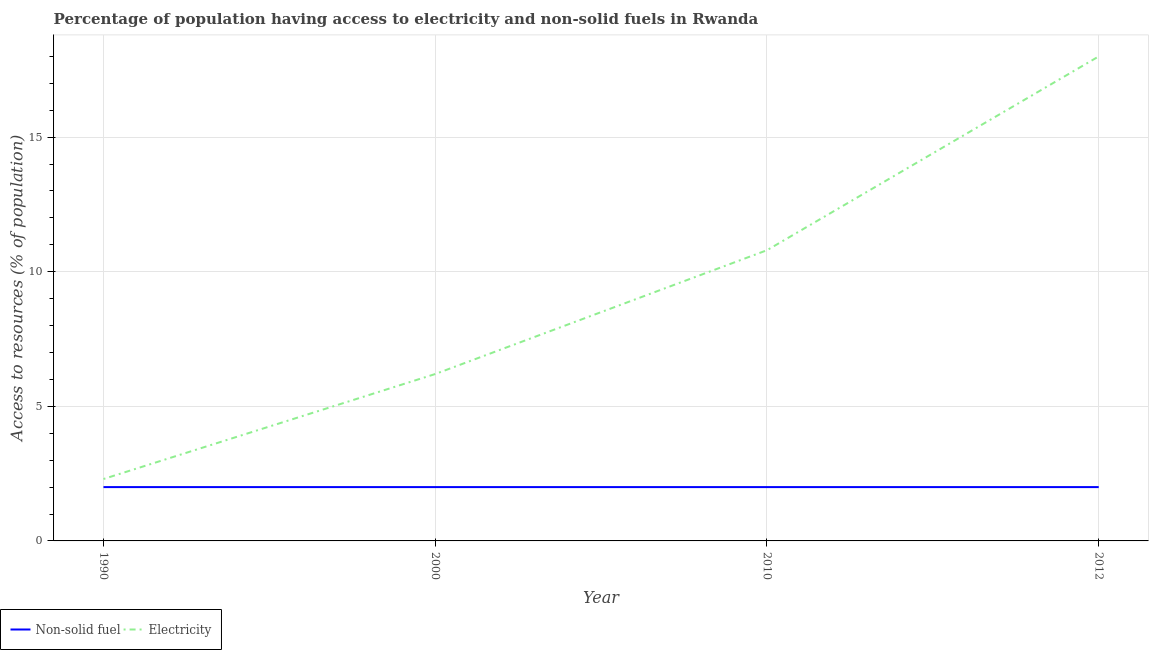Is the number of lines equal to the number of legend labels?
Give a very brief answer. Yes. In which year was the percentage of population having access to non-solid fuel maximum?
Your answer should be compact. 1990. What is the total percentage of population having access to electricity in the graph?
Keep it short and to the point. 37.3. What is the difference between the percentage of population having access to non-solid fuel in 1990 and that in 2010?
Ensure brevity in your answer.  0. What is the difference between the percentage of population having access to electricity in 2010 and the percentage of population having access to non-solid fuel in 2012?
Make the answer very short. 8.8. What is the average percentage of population having access to non-solid fuel per year?
Give a very brief answer. 2. In the year 2012, what is the difference between the percentage of population having access to electricity and percentage of population having access to non-solid fuel?
Offer a very short reply. 16. Is the percentage of population having access to non-solid fuel strictly greater than the percentage of population having access to electricity over the years?
Give a very brief answer. No. Is the percentage of population having access to non-solid fuel strictly less than the percentage of population having access to electricity over the years?
Give a very brief answer. Yes. What is the difference between two consecutive major ticks on the Y-axis?
Your answer should be very brief. 5. Are the values on the major ticks of Y-axis written in scientific E-notation?
Give a very brief answer. No. Does the graph contain any zero values?
Give a very brief answer. No. Does the graph contain grids?
Make the answer very short. Yes. How are the legend labels stacked?
Make the answer very short. Horizontal. What is the title of the graph?
Make the answer very short. Percentage of population having access to electricity and non-solid fuels in Rwanda. What is the label or title of the X-axis?
Your response must be concise. Year. What is the label or title of the Y-axis?
Offer a very short reply. Access to resources (% of population). What is the Access to resources (% of population) of Non-solid fuel in 1990?
Keep it short and to the point. 2. What is the Access to resources (% of population) in Electricity in 1990?
Give a very brief answer. 2.3. What is the Access to resources (% of population) in Non-solid fuel in 2000?
Your answer should be compact. 2. What is the Access to resources (% of population) in Non-solid fuel in 2010?
Provide a short and direct response. 2. What is the Access to resources (% of population) in Non-solid fuel in 2012?
Make the answer very short. 2. Across all years, what is the maximum Access to resources (% of population) of Non-solid fuel?
Keep it short and to the point. 2. Across all years, what is the minimum Access to resources (% of population) in Non-solid fuel?
Give a very brief answer. 2. What is the total Access to resources (% of population) of Non-solid fuel in the graph?
Give a very brief answer. 8. What is the total Access to resources (% of population) in Electricity in the graph?
Offer a terse response. 37.3. What is the difference between the Access to resources (% of population) of Electricity in 1990 and that in 2010?
Offer a terse response. -8.5. What is the difference between the Access to resources (% of population) in Electricity in 1990 and that in 2012?
Provide a short and direct response. -15.7. What is the difference between the Access to resources (% of population) in Electricity in 2010 and that in 2012?
Provide a succinct answer. -7.2. What is the difference between the Access to resources (% of population) of Non-solid fuel in 1990 and the Access to resources (% of population) of Electricity in 2000?
Your answer should be compact. -4.2. What is the difference between the Access to resources (% of population) in Non-solid fuel in 2000 and the Access to resources (% of population) in Electricity in 2010?
Offer a very short reply. -8.8. What is the difference between the Access to resources (% of population) of Non-solid fuel in 2000 and the Access to resources (% of population) of Electricity in 2012?
Make the answer very short. -16. What is the difference between the Access to resources (% of population) in Non-solid fuel in 2010 and the Access to resources (% of population) in Electricity in 2012?
Make the answer very short. -16. What is the average Access to resources (% of population) of Non-solid fuel per year?
Your answer should be very brief. 2. What is the average Access to resources (% of population) of Electricity per year?
Provide a short and direct response. 9.32. In the year 2000, what is the difference between the Access to resources (% of population) of Non-solid fuel and Access to resources (% of population) of Electricity?
Provide a succinct answer. -4.2. In the year 2010, what is the difference between the Access to resources (% of population) in Non-solid fuel and Access to resources (% of population) in Electricity?
Provide a succinct answer. -8.8. In the year 2012, what is the difference between the Access to resources (% of population) in Non-solid fuel and Access to resources (% of population) in Electricity?
Your answer should be compact. -16. What is the ratio of the Access to resources (% of population) of Electricity in 1990 to that in 2000?
Provide a short and direct response. 0.37. What is the ratio of the Access to resources (% of population) in Electricity in 1990 to that in 2010?
Provide a short and direct response. 0.21. What is the ratio of the Access to resources (% of population) in Electricity in 1990 to that in 2012?
Offer a very short reply. 0.13. What is the ratio of the Access to resources (% of population) of Electricity in 2000 to that in 2010?
Your answer should be very brief. 0.57. What is the ratio of the Access to resources (% of population) of Electricity in 2000 to that in 2012?
Provide a succinct answer. 0.34. What is the ratio of the Access to resources (% of population) in Electricity in 2010 to that in 2012?
Your answer should be compact. 0.6. What is the difference between the highest and the second highest Access to resources (% of population) of Non-solid fuel?
Keep it short and to the point. 0. What is the difference between the highest and the lowest Access to resources (% of population) in Non-solid fuel?
Your answer should be compact. 0. What is the difference between the highest and the lowest Access to resources (% of population) in Electricity?
Ensure brevity in your answer.  15.7. 